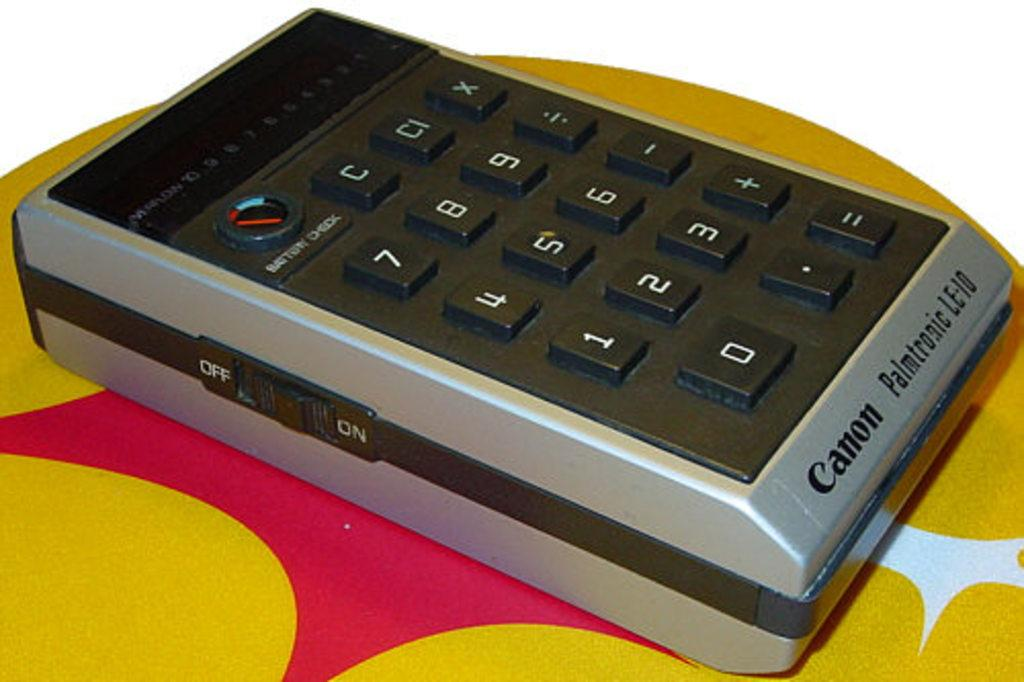<image>
Relay a brief, clear account of the picture shown. A black and silver Cannon Palmtrogic LE-10 calculator. 